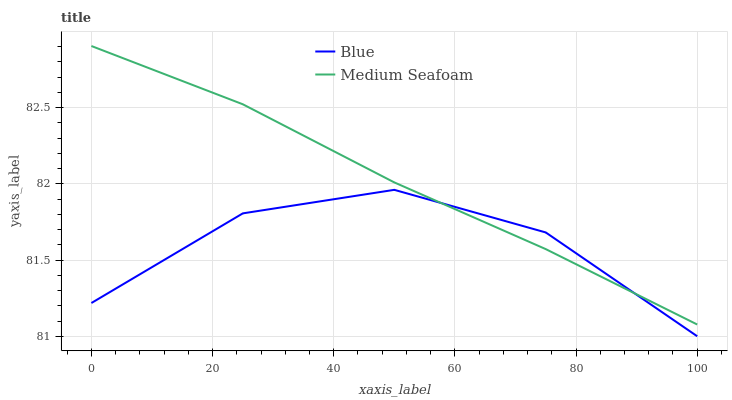Does Blue have the minimum area under the curve?
Answer yes or no. Yes. Does Medium Seafoam have the maximum area under the curve?
Answer yes or no. Yes. Does Medium Seafoam have the minimum area under the curve?
Answer yes or no. No. Is Medium Seafoam the smoothest?
Answer yes or no. Yes. Is Blue the roughest?
Answer yes or no. Yes. Is Medium Seafoam the roughest?
Answer yes or no. No. Does Medium Seafoam have the lowest value?
Answer yes or no. No. Does Medium Seafoam have the highest value?
Answer yes or no. Yes. Does Medium Seafoam intersect Blue?
Answer yes or no. Yes. Is Medium Seafoam less than Blue?
Answer yes or no. No. Is Medium Seafoam greater than Blue?
Answer yes or no. No. 